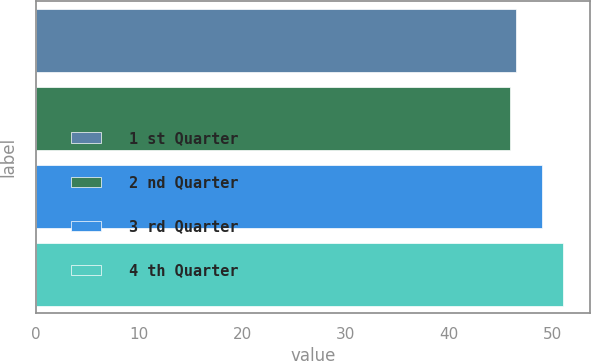<chart> <loc_0><loc_0><loc_500><loc_500><bar_chart><fcel>1 st Quarter<fcel>2 nd Quarter<fcel>3 rd Quarter<fcel>4 th Quarter<nl><fcel>46.45<fcel>45.83<fcel>48.94<fcel>51.03<nl></chart> 